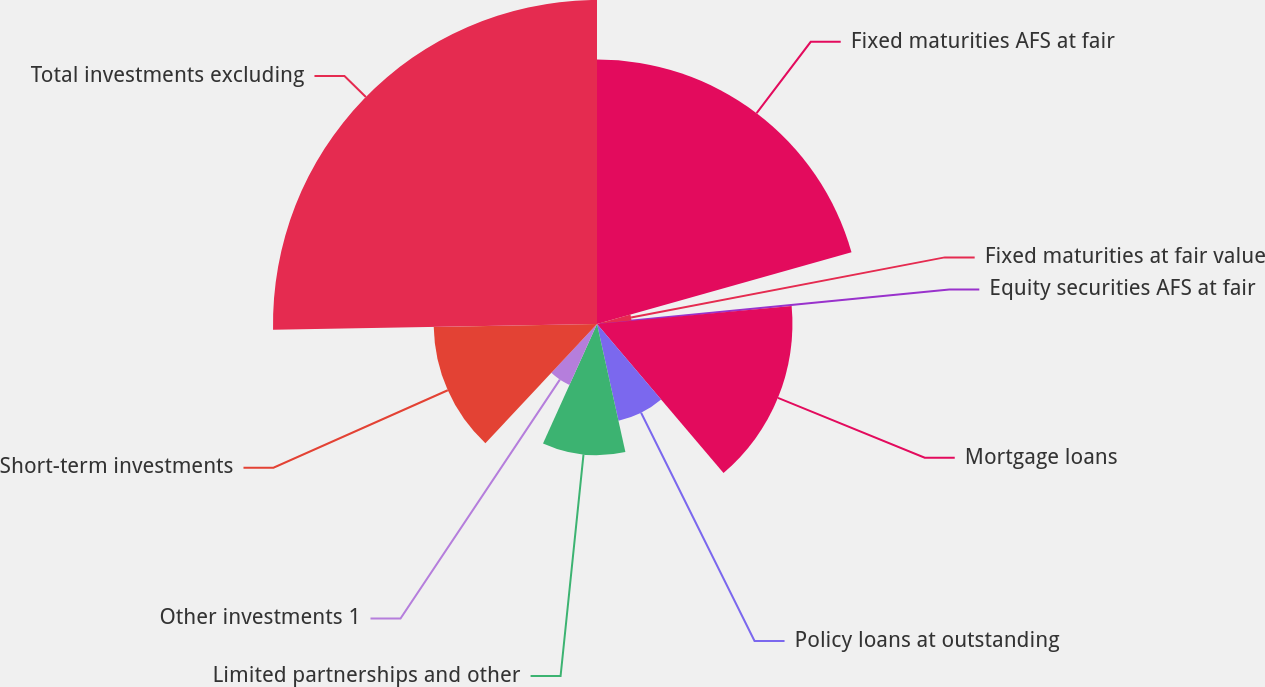<chart> <loc_0><loc_0><loc_500><loc_500><pie_chart><fcel>Fixed maturities AFS at fair<fcel>Fixed maturities at fair value<fcel>Equity securities AFS at fair<fcel>Mortgage loans<fcel>Policy loans at outstanding<fcel>Limited partnerships and other<fcel>Other investments 1<fcel>Short-term investments<fcel>Total investments excluding<nl><fcel>20.63%<fcel>2.71%<fcel>0.2%<fcel>15.25%<fcel>7.73%<fcel>10.23%<fcel>5.22%<fcel>12.74%<fcel>25.28%<nl></chart> 